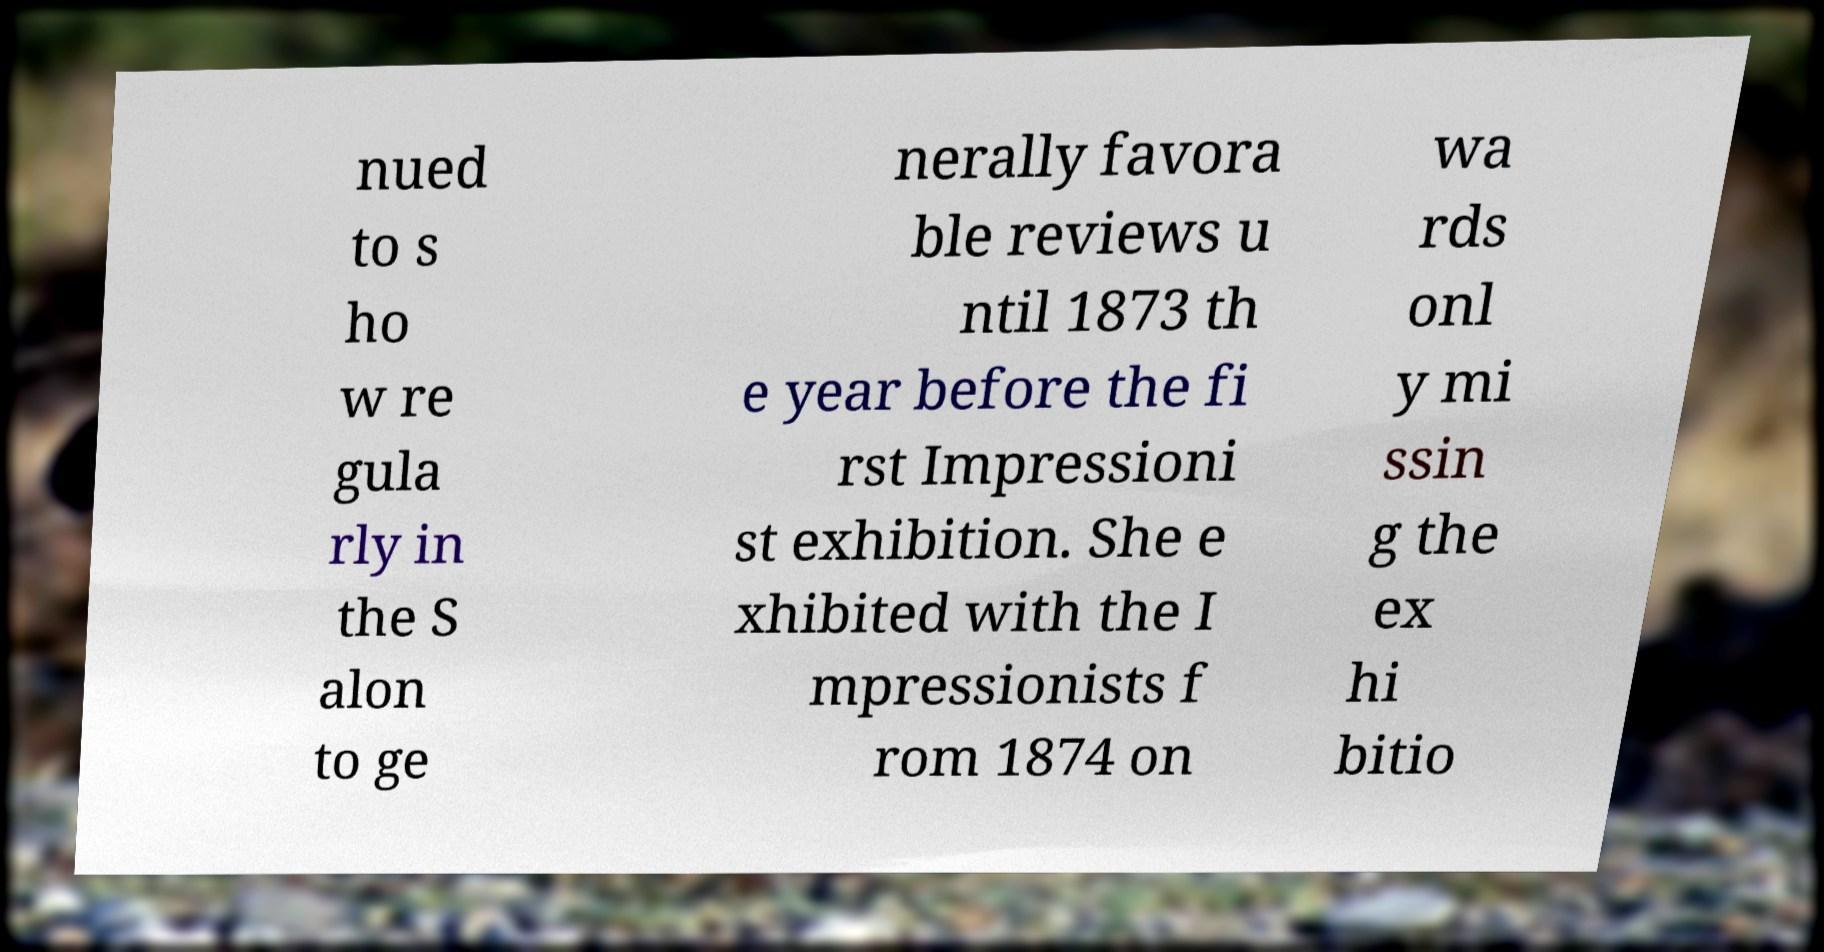For documentation purposes, I need the text within this image transcribed. Could you provide that? nued to s ho w re gula rly in the S alon to ge nerally favora ble reviews u ntil 1873 th e year before the fi rst Impressioni st exhibition. She e xhibited with the I mpressionists f rom 1874 on wa rds onl y mi ssin g the ex hi bitio 